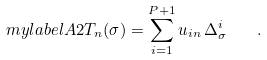Convert formula to latex. <formula><loc_0><loc_0><loc_500><loc_500>\ m y l a b e l { A 2 } T _ { n } ( \sigma ) = \sum _ { i = 1 } ^ { P + 1 } u _ { i n } \, \Delta _ { \sigma } ^ { i } \quad .</formula> 